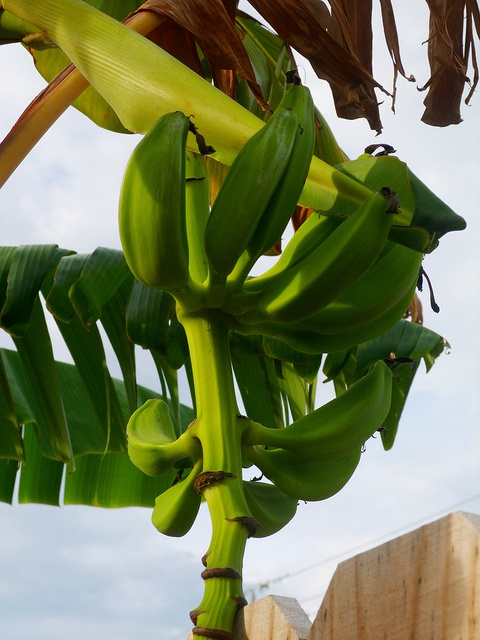Describe the objects in this image and their specific colors. I can see banana in olive and darkgreen tones, banana in olive, darkgreen, and lightgray tones, banana in olive and darkgreen tones, banana in olive and darkgreen tones, and banana in olive, darkgreen, and white tones in this image. 